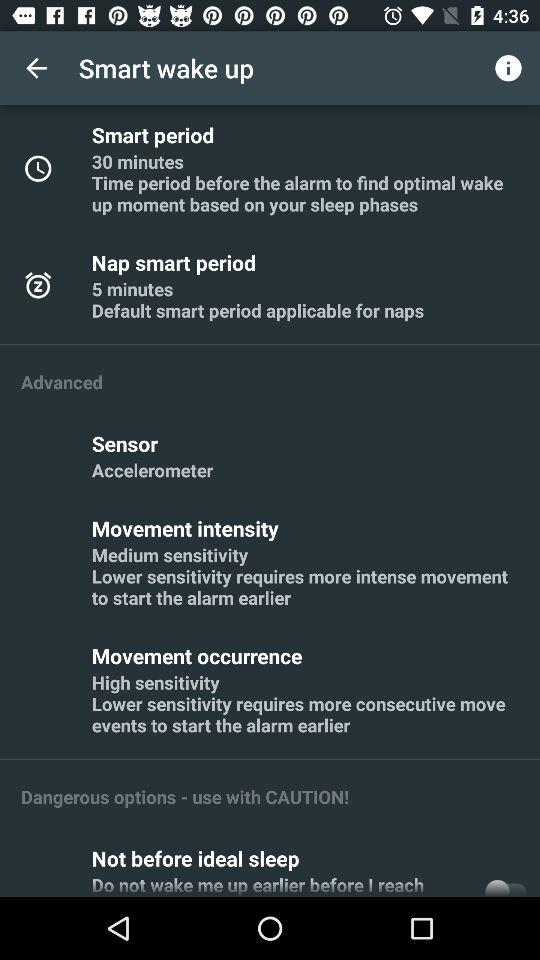Is there another option of "Smart period" other than 30 minutes?
When the provided information is insufficient, respond with <no answer>. <no answer> 